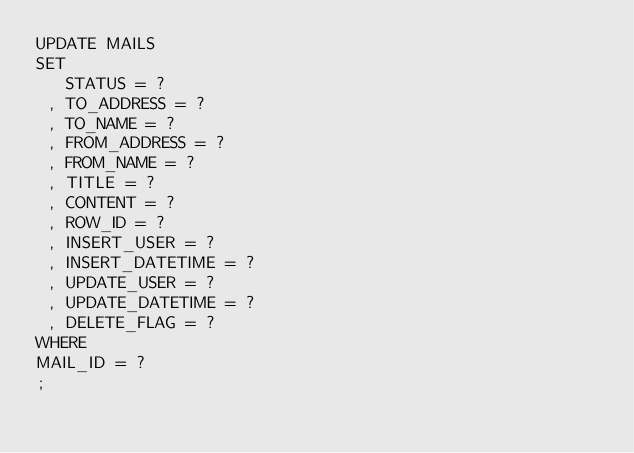<code> <loc_0><loc_0><loc_500><loc_500><_SQL_>UPDATE MAILS
SET 
   STATUS = ?
 , TO_ADDRESS = ?
 , TO_NAME = ?
 , FROM_ADDRESS = ?
 , FROM_NAME = ?
 , TITLE = ?
 , CONTENT = ?
 , ROW_ID = ?
 , INSERT_USER = ?
 , INSERT_DATETIME = ?
 , UPDATE_USER = ?
 , UPDATE_DATETIME = ?
 , DELETE_FLAG = ?
WHERE 
MAIL_ID = ?
;
</code> 